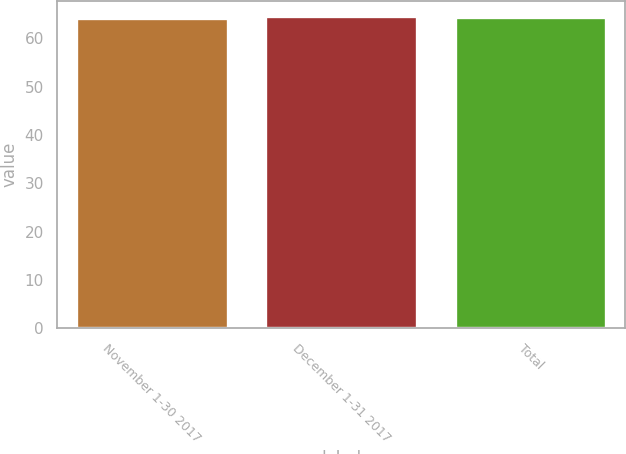<chart> <loc_0><loc_0><loc_500><loc_500><bar_chart><fcel>November 1-30 2017<fcel>December 1-31 2017<fcel>Total<nl><fcel>64.33<fcel>64.58<fcel>64.52<nl></chart> 